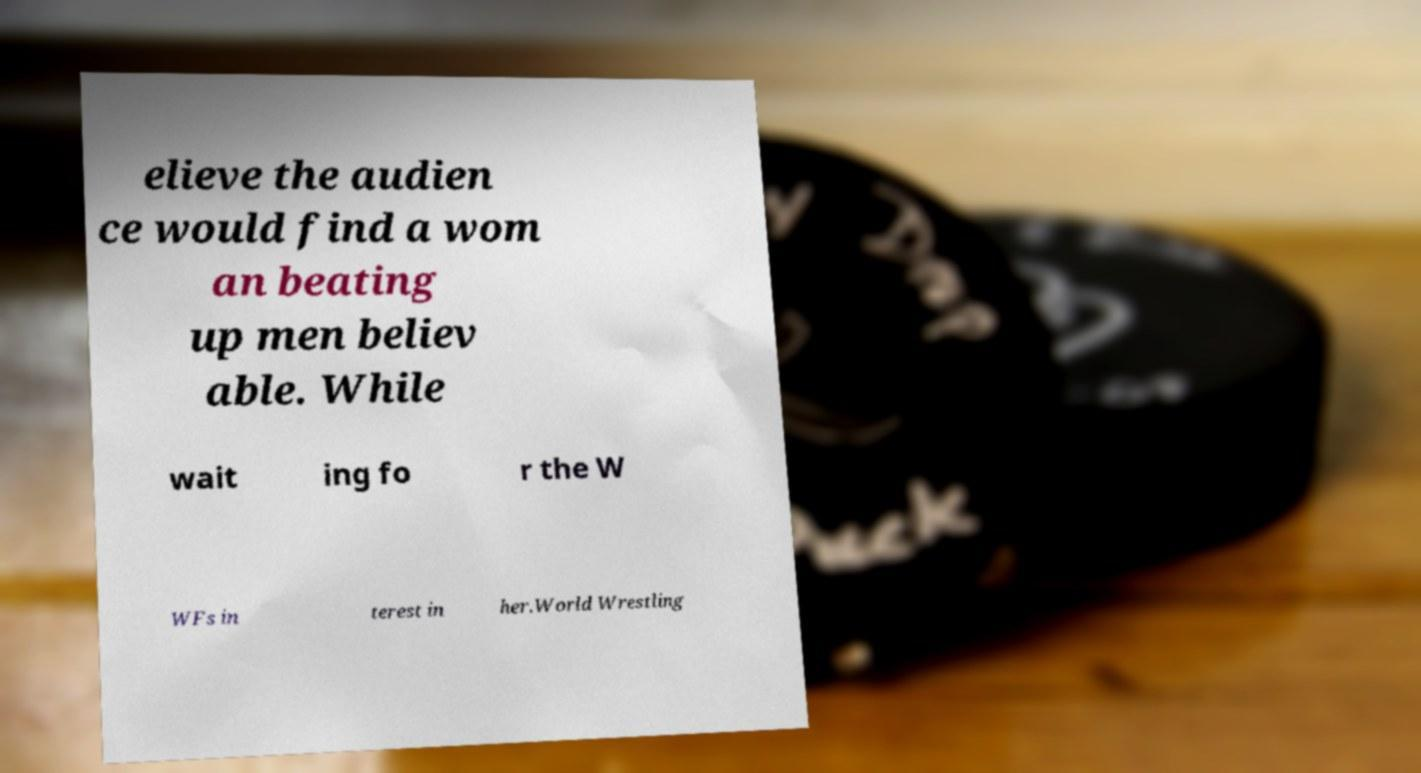There's text embedded in this image that I need extracted. Can you transcribe it verbatim? elieve the audien ce would find a wom an beating up men believ able. While wait ing fo r the W WFs in terest in her.World Wrestling 